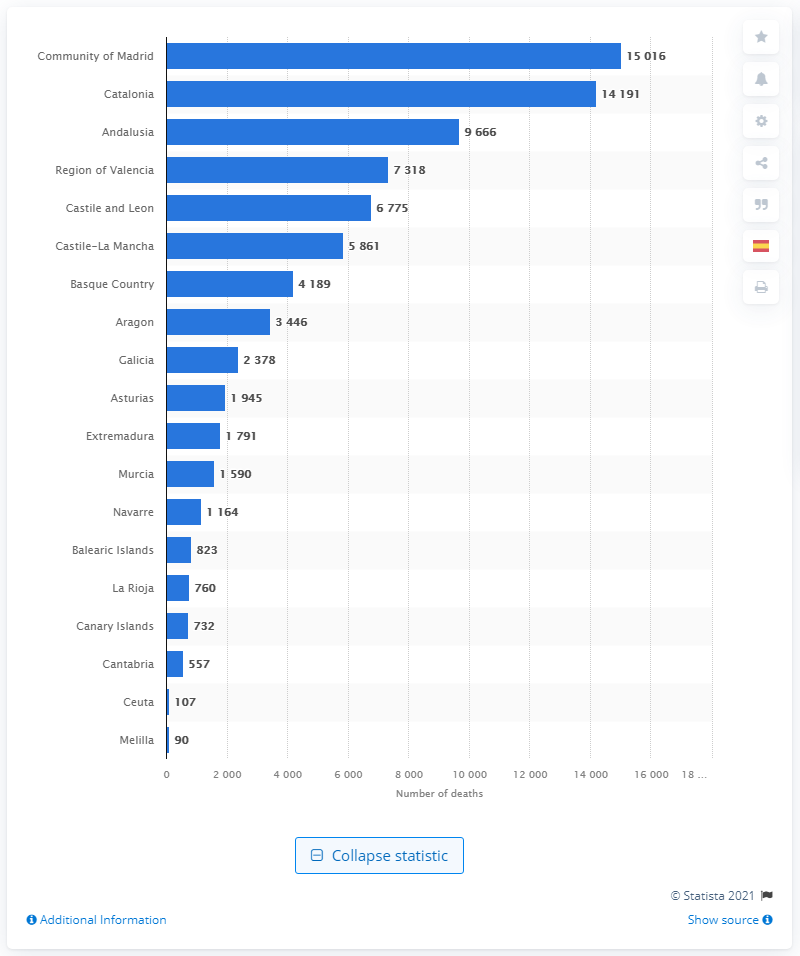Which regions have the lowest number of deaths according to this data? Based on the chart, the regions with the lowest number of deaths are Melilla and Ceuta, with 90 and 107 deaths respectively. 